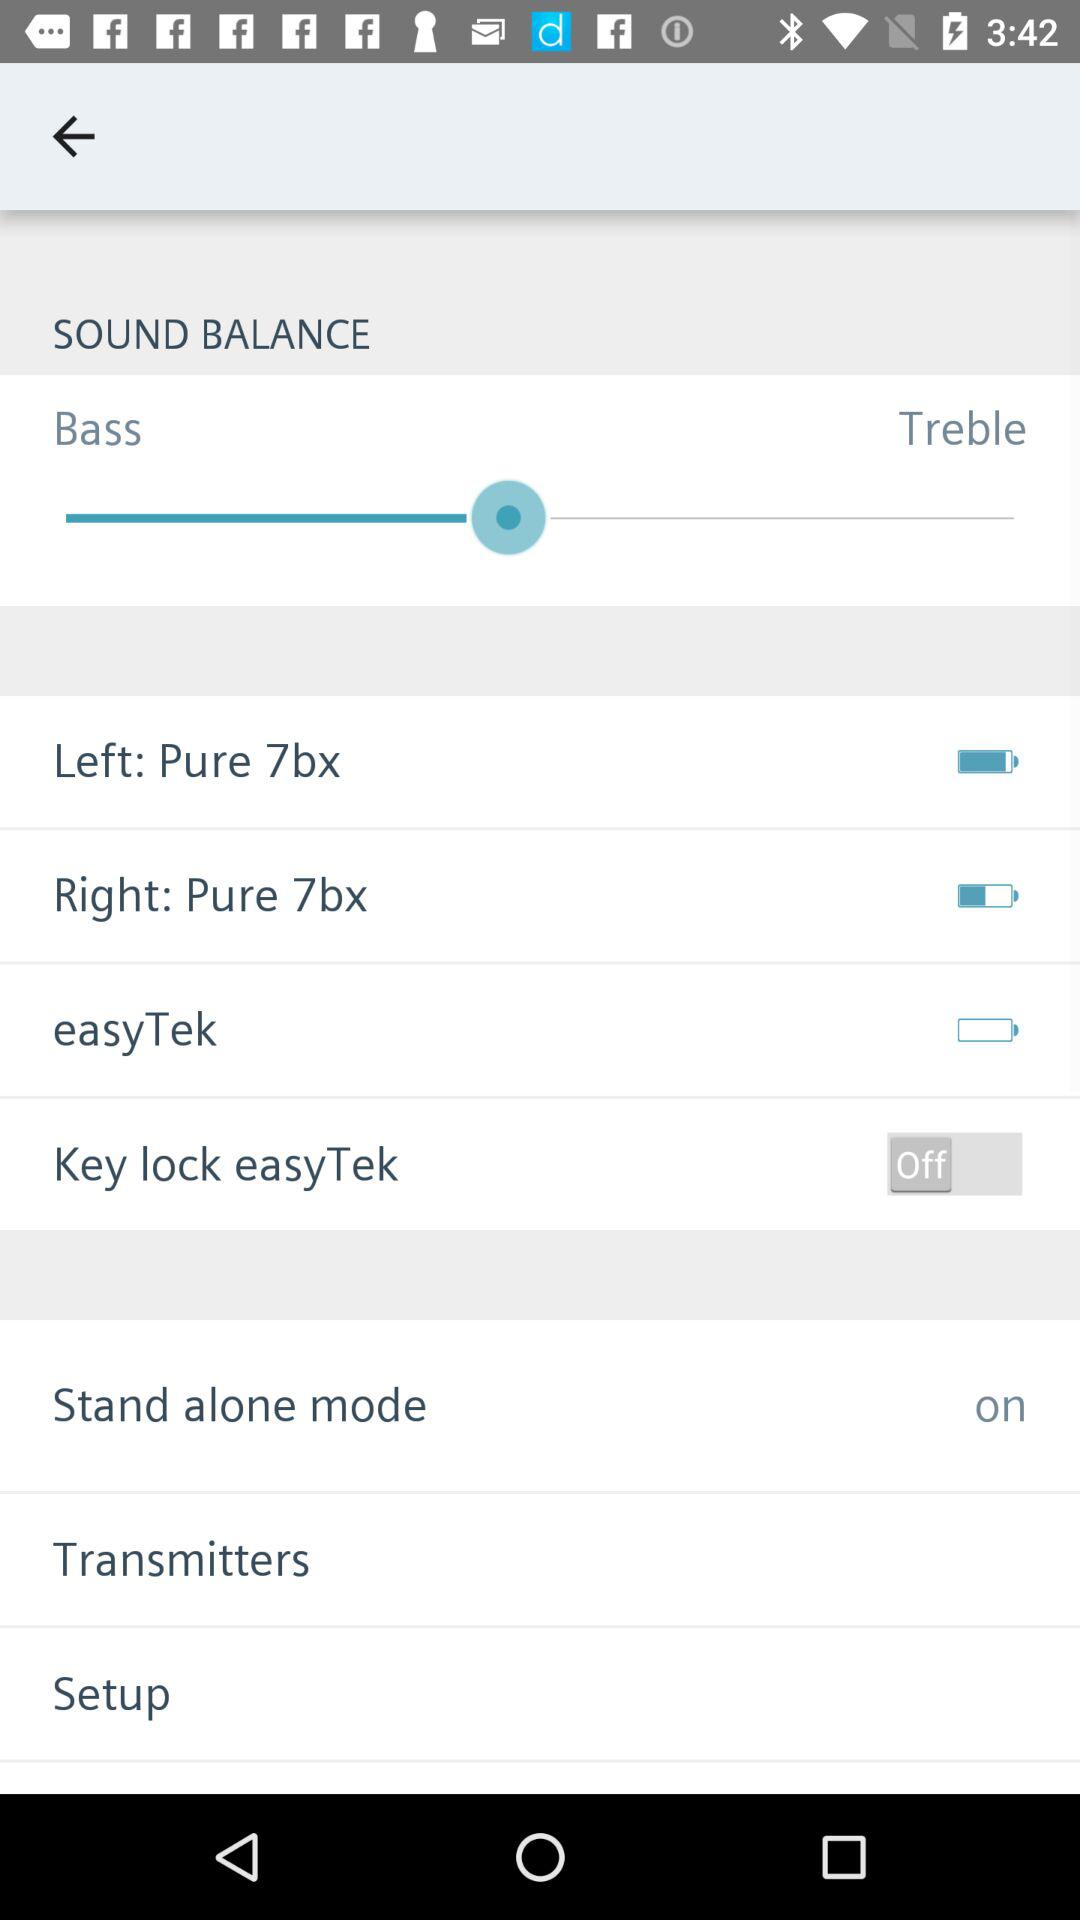How many options are available for the sound balance?
Answer the question using a single word or phrase. 2 